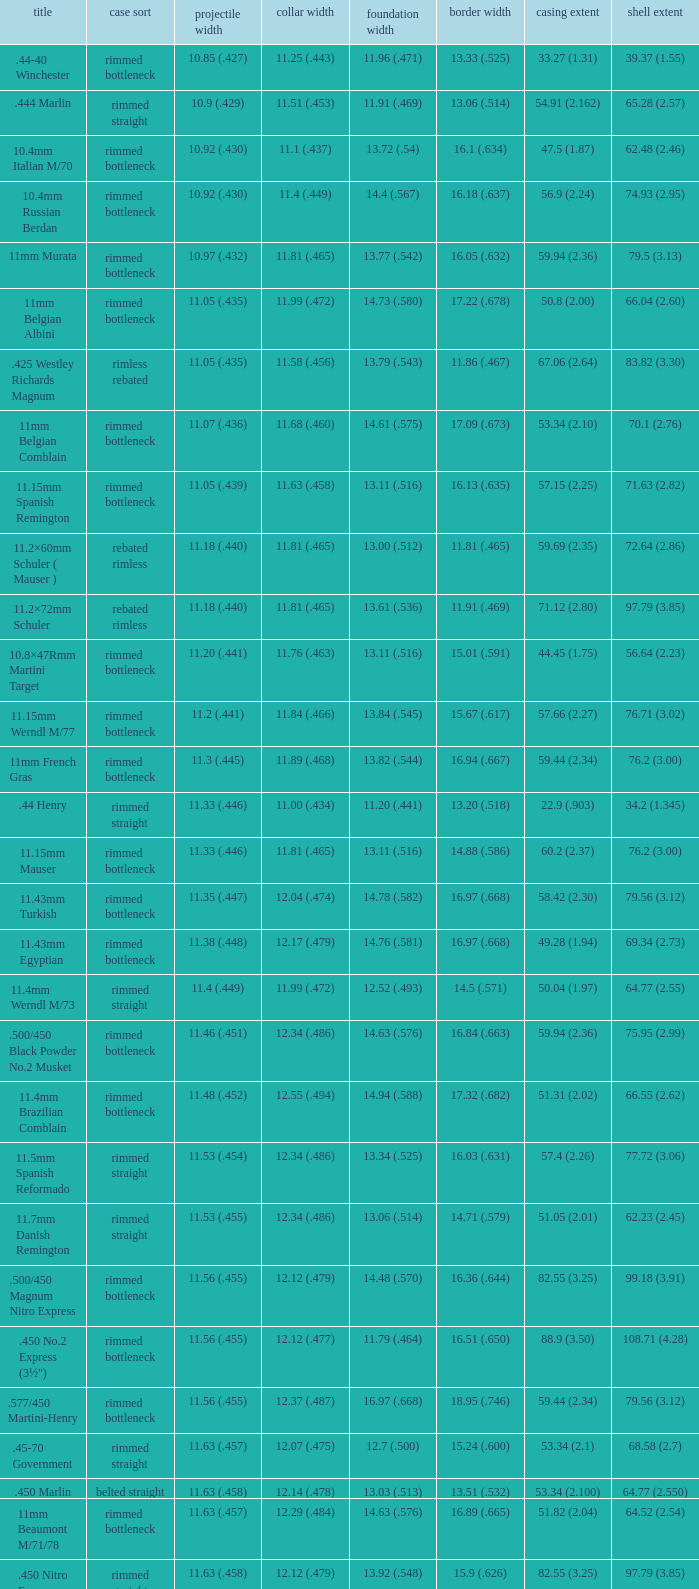Which Case length has a Rim diameter of 13.20 (.518)? 22.9 (.903). 